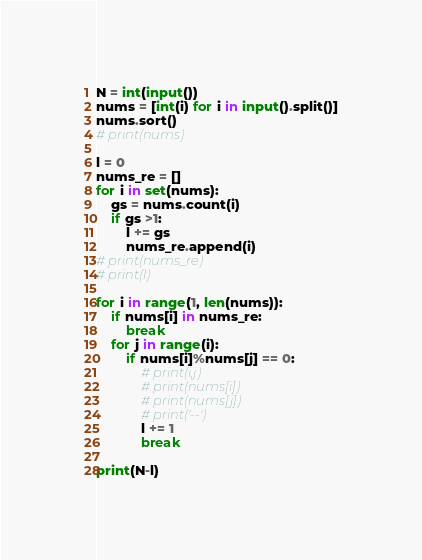<code> <loc_0><loc_0><loc_500><loc_500><_Python_>N = int(input())
nums = [int(i) for i in input().split()]
nums.sort()
# print(nums)

l = 0
nums_re = []
for i in set(nums):
    gs = nums.count(i)
    if gs >1:
        l += gs
        nums_re.append(i)
# print(nums_re)
# print(l)

for i in range(1, len(nums)):
    if nums[i] in nums_re:
        break
    for j in range(i):
        if nums[i]%nums[j] == 0:
            # print(i,j)
            # print(nums[i])
            # print(nums[j])
            # print('--')
            l += 1
            break
        
print(N-l)</code> 